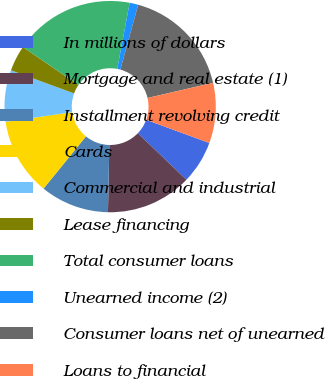Convert chart to OTSL. <chart><loc_0><loc_0><loc_500><loc_500><pie_chart><fcel>In millions of dollars<fcel>Mortgage and real estate (1)<fcel>Installment revolving credit<fcel>Cards<fcel>Commercial and industrial<fcel>Lease financing<fcel>Total consumer loans<fcel>Unearned income (2)<fcel>Consumer loans net of unearned<fcel>Loans to financial<nl><fcel>6.58%<fcel>13.16%<fcel>10.53%<fcel>11.84%<fcel>7.89%<fcel>3.95%<fcel>18.42%<fcel>1.32%<fcel>17.11%<fcel>9.21%<nl></chart> 